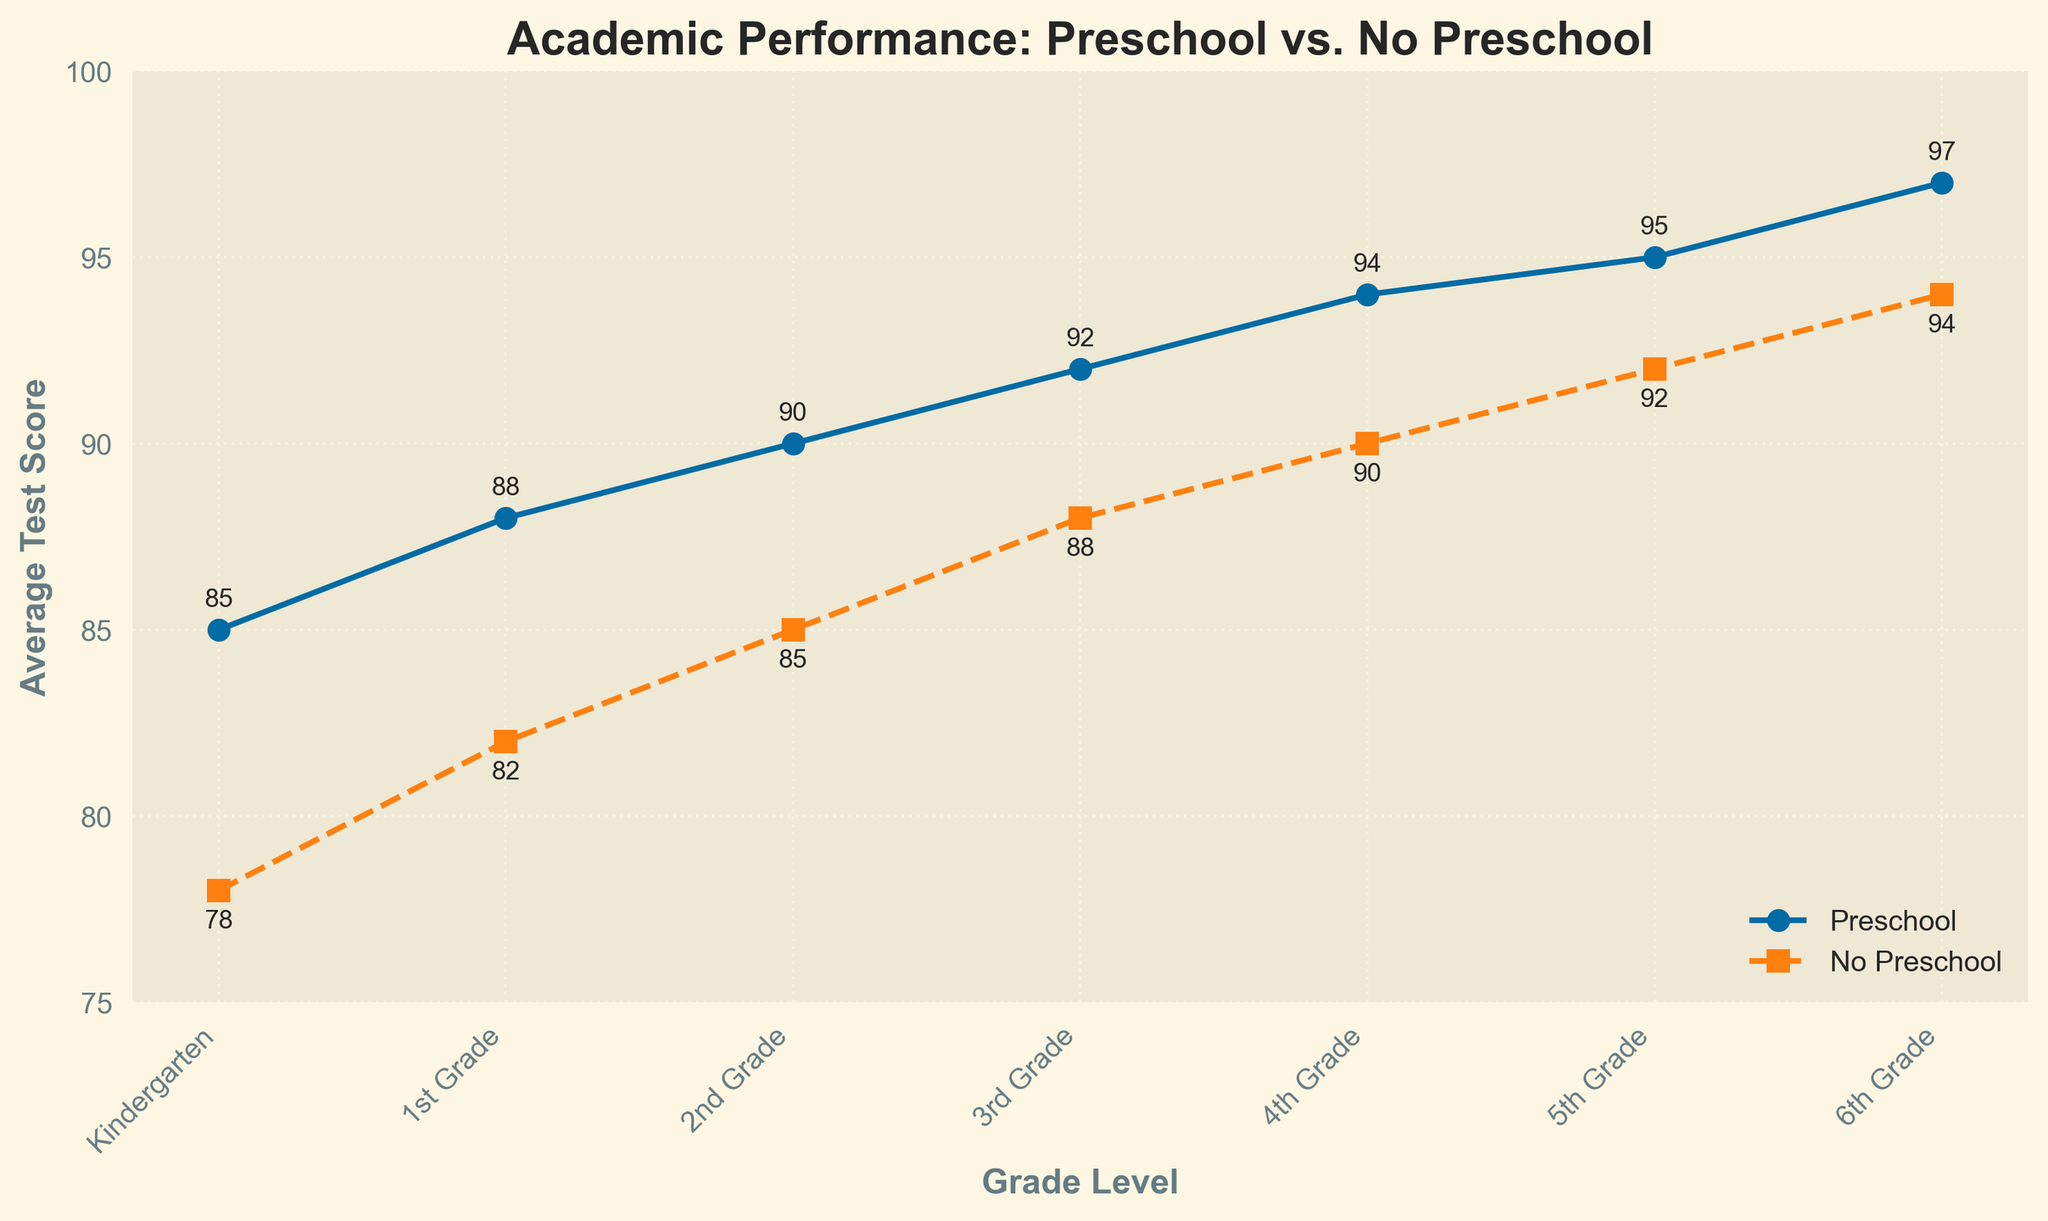Which grade shows the largest difference in average test scores between children who attended preschool and those who did not? To find the largest difference, we need to calculate the differences for each grade: Kindergarten (85-78 = 7), 1st Grade (88-82 = 6), 2nd Grade (90-85 = 5), 3rd Grade (92-88 = 4), 4th Grade (94-90 = 4), 5th Grade (95-92 = 3), 6th Grade (97-94 = 3). The largest difference is 7 in Kindergarten.
Answer: Kindergarten Which group shows a consistently higher average test score across all grade levels? By looking at the lines on the graph, we see that the line representing children who attended preschool is consistently above the line for those who did not attend preschool at all grade levels.
Answer: Children who attended preschool By how much did the average test score for children who attended preschool increase from Kindergarten to 6th Grade? The average test score for children who attended preschool in Kindergarten is 85, and it increases to 97 by 6th Grade. The increase is 97 - 85 = 12.
Answer: 12 points What was the average test score for children who did not attend preschool in 2nd Grade? Referring to the line representing children who did not attend preschool, the average test score in 2nd Grade is 85.
Answer: 85 How much higher was the average test score for children who attended preschool compared to those who did not in 4th Grade? The average test scores for 4th Grade are 94 for those who attended preschool and 90 for those who did not. The difference is 94 - 90 = 4.
Answer: 4 points In which grade do children who attended preschool have an average test score close to 90? By examining the data points, children who attended preschool have an average test score of 90 in 2nd Grade.
Answer: 2nd Grade What is the trend in average test scores for both groups from Kindergarten to 6th Grade? Both lines show an increasing trend in average test scores from Kindergarten to 6th Grade, with test scores steadily rising for both children who attended preschool and those who did not.
Answer: Increasing trend What is the average test score of children who attended preschool in 3rd Grade, and how does it compare to their peers who did not attend preschool? The average test score for children who attended preschool in 3rd Grade is 92, while it is 88 for those who did not attend preschool. The comparison shows that the score is 4 points higher for the preschool group.
Answer: 92, 4 points higher 